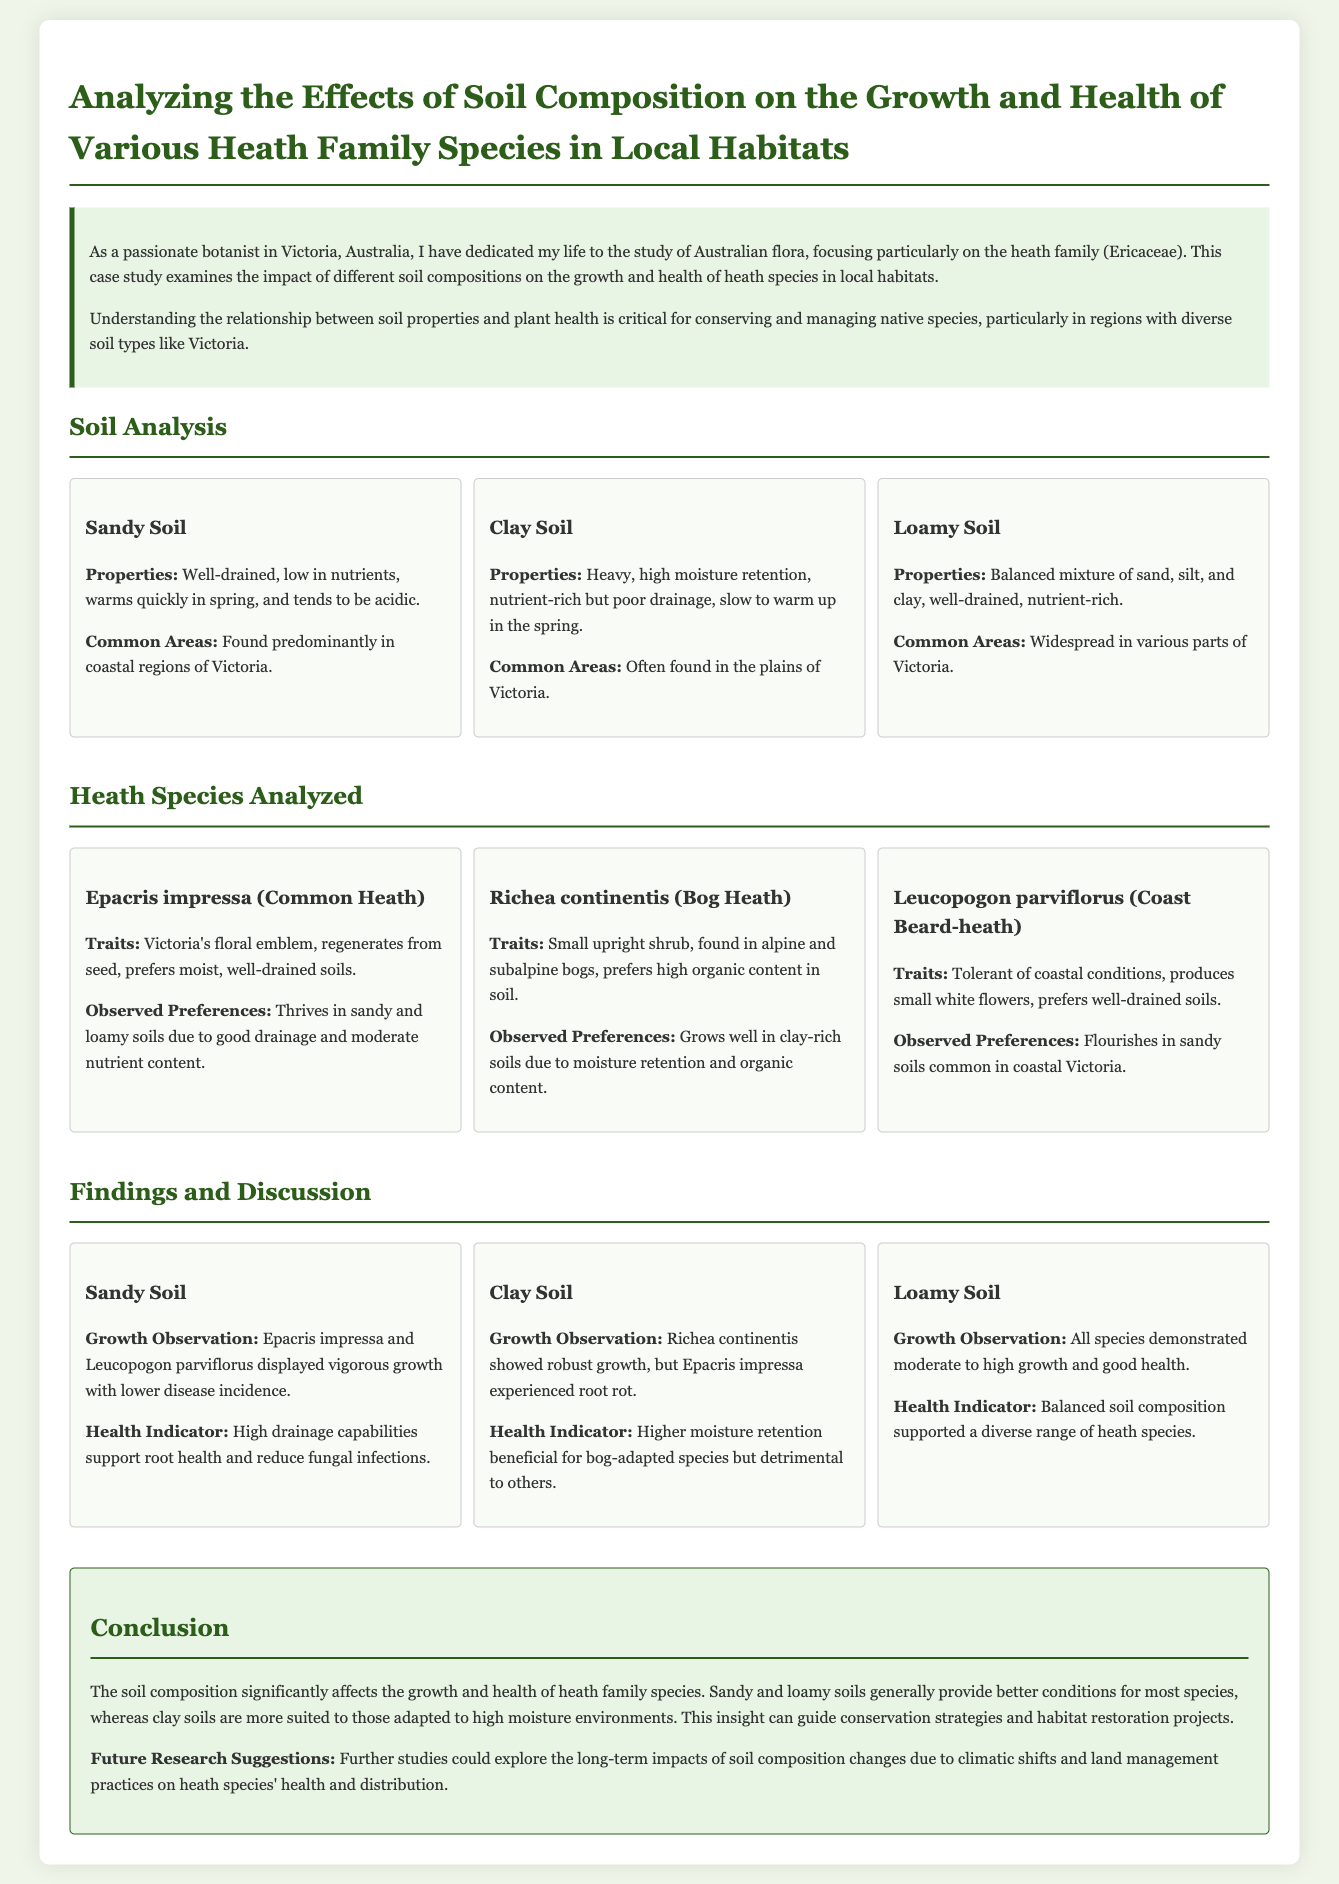what is the purpose of the case study? The case study examines the impact of different soil compositions on the growth and health of heath species in local habitats.
Answer: impact of different soil compositions on the growth and health of heath species what is Victoria’s floral emblem? The document mentions Epacris impressa as Victoria's floral emblem.
Answer: Epacris impressa which soil type is characterized as heavy with high moisture retention? According to the document, clay soil is described as heavy and high moisture retention.
Answer: Clay Soil which heath species prefers high organic content in soil? The species Richea continentis is noted for preferring high organic content in soil.
Answer: Richea continentis what soil type supports vigorous growth for Epacris impressa? The document states that Epacris impressa displayed vigorous growth in sandy soil.
Answer: Sandy Soil how did Richea continentis perform in clay soil? The document notes that Richea continentis showed robust growth in clay soil.
Answer: robust growth which soil type is most suitable for bog-adapted species? The findings indicate that clay soil is more suitable for bog-adapted species.
Answer: Clay Soil what is the general conclusion about soil composition's effect on heath species? The conclusion states that sandy and loamy soils generally provide better conditions for most species.
Answer: sandy and loamy soils generally provide better conditions 